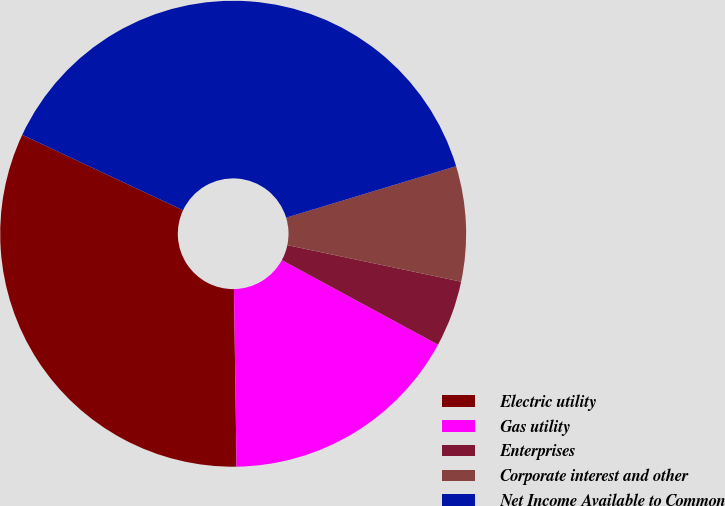Convert chart. <chart><loc_0><loc_0><loc_500><loc_500><pie_chart><fcel>Electric utility<fcel>Gas utility<fcel>Enterprises<fcel>Corporate interest and other<fcel>Net Income Available to Common<nl><fcel>32.21%<fcel>16.87%<fcel>4.6%<fcel>7.98%<fcel>38.34%<nl></chart> 